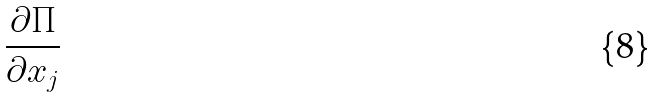<formula> <loc_0><loc_0><loc_500><loc_500>\frac { \partial \Pi } { \partial x _ { j } }</formula> 